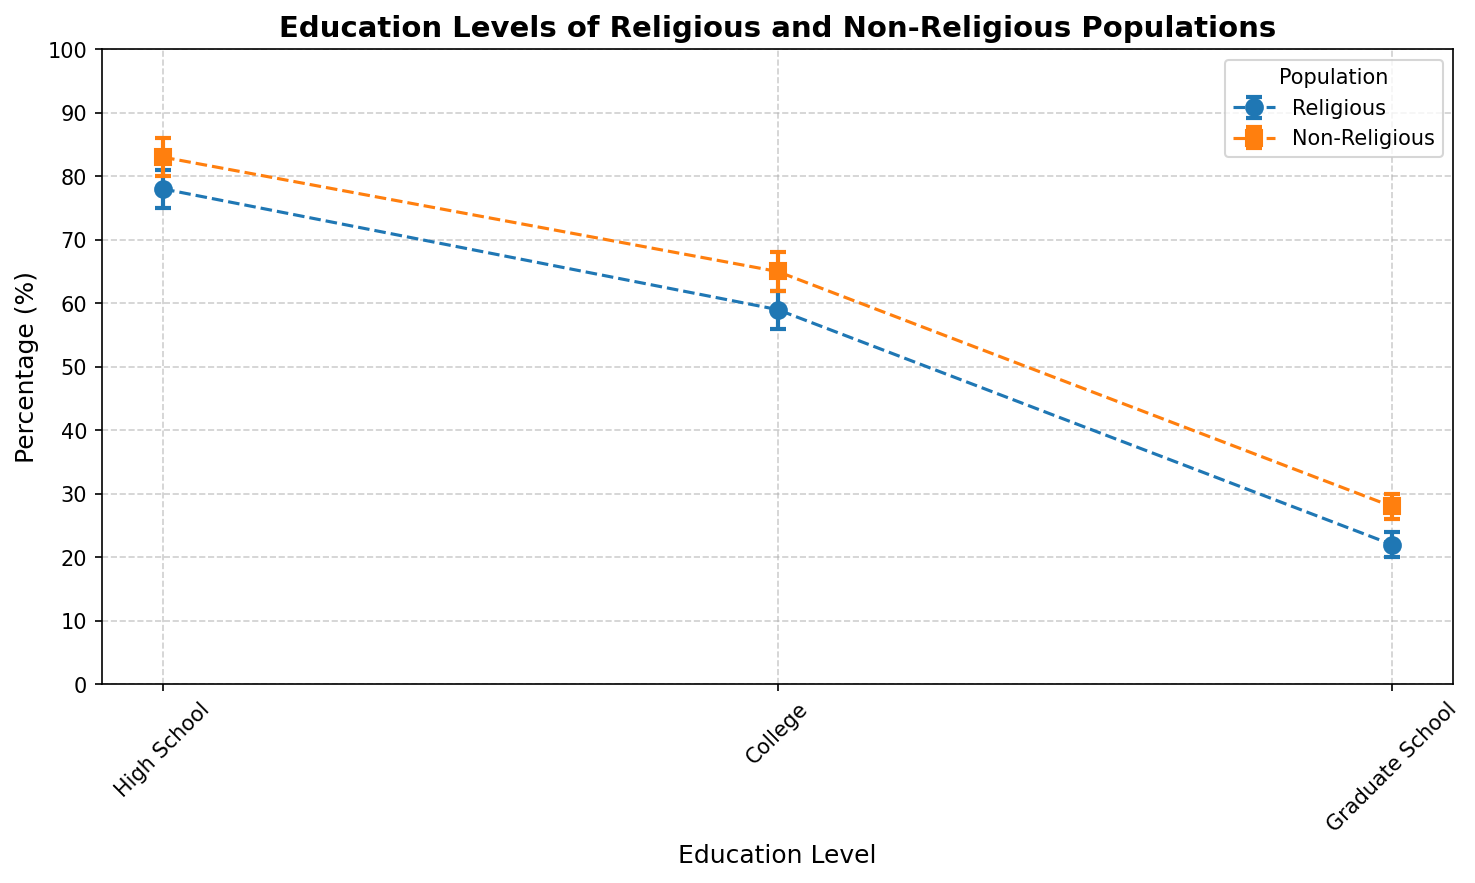What is the percentage range for High School education in the Religious population? The High School education level for the Religious population has a mean of 78%, with a lower bound of 75% and an upper bound of 81%. This gives a range of 75% to 81%.
Answer: 75% to 81% How does the average percentage of College education compare between Religious and Non-Religious populations? The mean percentage of College education is 59% for the Religious population and 65% for the Non-Religious population. Therefore, the Non-Religious population has a higher average by 6 percentage points.
Answer: Non-Religious is higher by 6% Between High School and Graduate School levels, which education level shows a greater difference in the means between Religious and Non-Religious populations? The difference for High School education is 83% - 78% = 5 percentage points. The difference for Graduate School education is 28% - 22% = 6 percentage points. Graduate School education shows a greater difference.
Answer: Graduate School What is the visual color difference between the data points representing Religious and Non-Religious populations? The data points for the Religious population are represented in blue, while the Non-Religious population is represented in orange. This can be identified by looking at the markers and error bars.
Answer: Blue for Religious, Orange for Non-Religious Which group has the largest upper bound for College education? The upper bound percentage for College education in Religious populations is 62%, and for Non-Religious populations, it is 68%. Therefore, the Non-Religious population has the largest upper bound for College education.
Answer: Non-Religious What's the average error range for Graduate School education across both populations? For the Religious population, the range is (24% - 20%) = 4%. For the Non-Religious population, the range is (30% - 26%) = 4%. The average error range is (4% + 4%) / 2 = 4%.
Answer: 4% Can you state which population has a higher mean percentage for High School education? The mean percentage for High School education is 78% for the Religious population and 83% for the Non-Religious population. Hence, the Non-Religious population has a higher mean percentage.
Answer: Non-Religious What is the difference in the lower bounds of the Graduate School education between Religious and Non-Religious populations? The lower bound for Graduate School education is 20% for the Religious population and 26% for the Non-Religious population. The difference is 26% - 20% = 6%.
Answer: 6% 